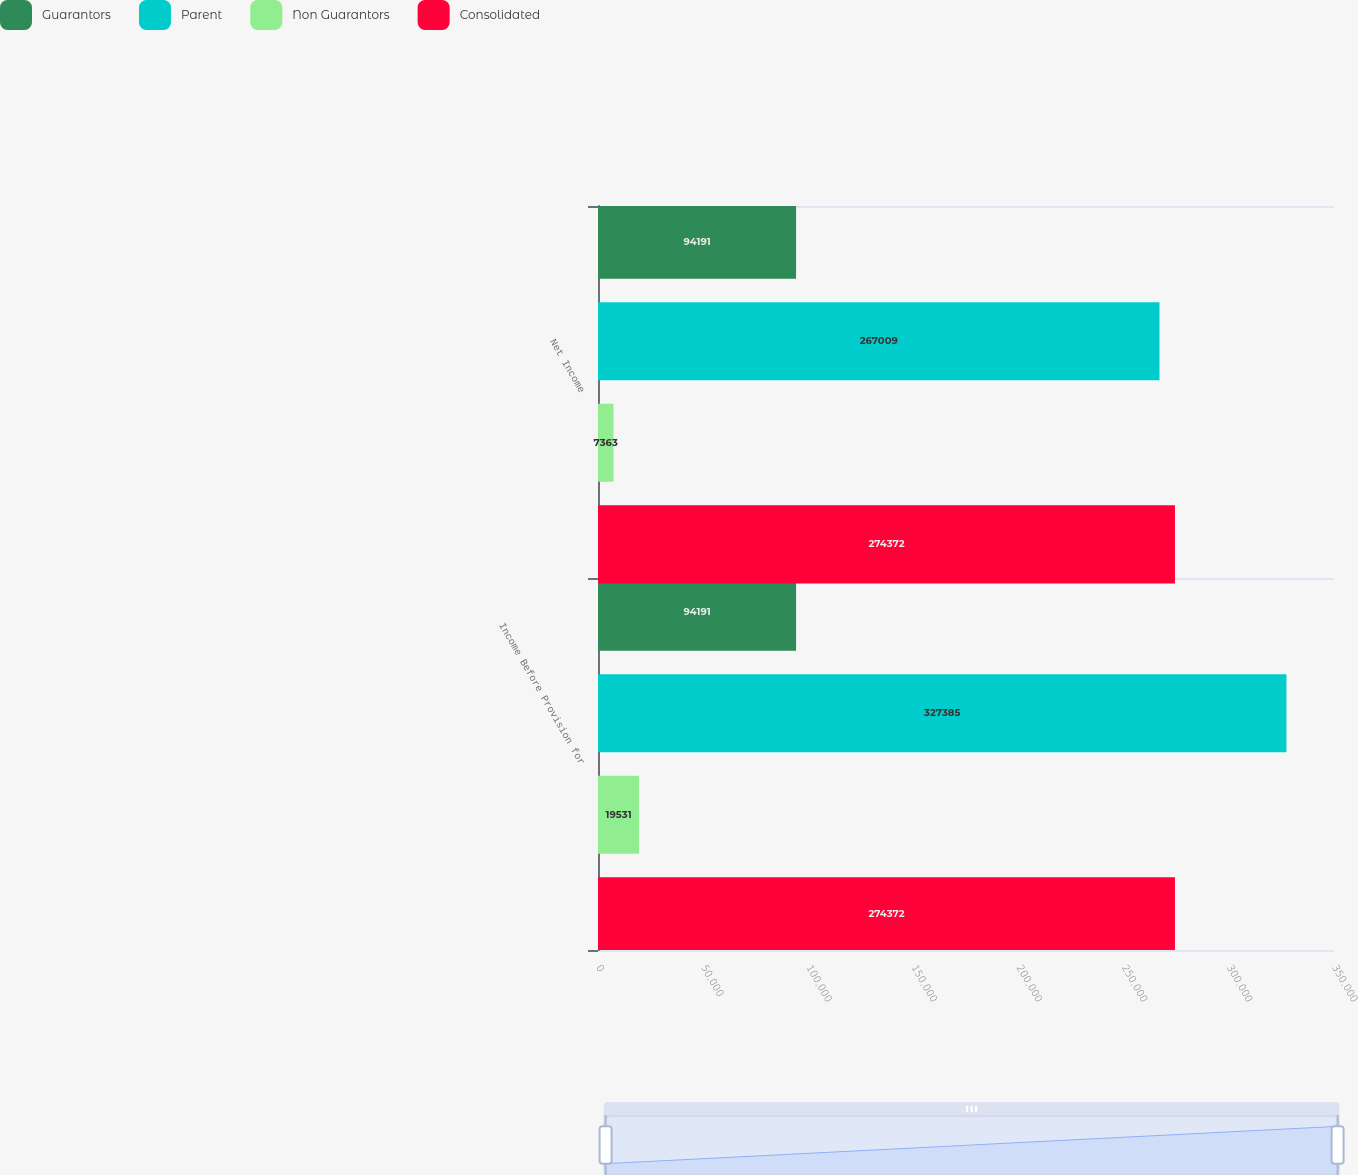Convert chart. <chart><loc_0><loc_0><loc_500><loc_500><stacked_bar_chart><ecel><fcel>Income Before Provision for<fcel>Net Income<nl><fcel>Guarantors<fcel>94191<fcel>94191<nl><fcel>Parent<fcel>327385<fcel>267009<nl><fcel>Non Guarantors<fcel>19531<fcel>7363<nl><fcel>Consolidated<fcel>274372<fcel>274372<nl></chart> 